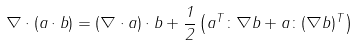Convert formula to latex. <formula><loc_0><loc_0><loc_500><loc_500>\nabla \cdot ( a \cdot b ) = ( \nabla \cdot a ) \cdot b + { \frac { 1 } { 2 } } \left ( a ^ { T } \colon \nabla b + a \colon ( \nabla b ) ^ { T } \right )</formula> 